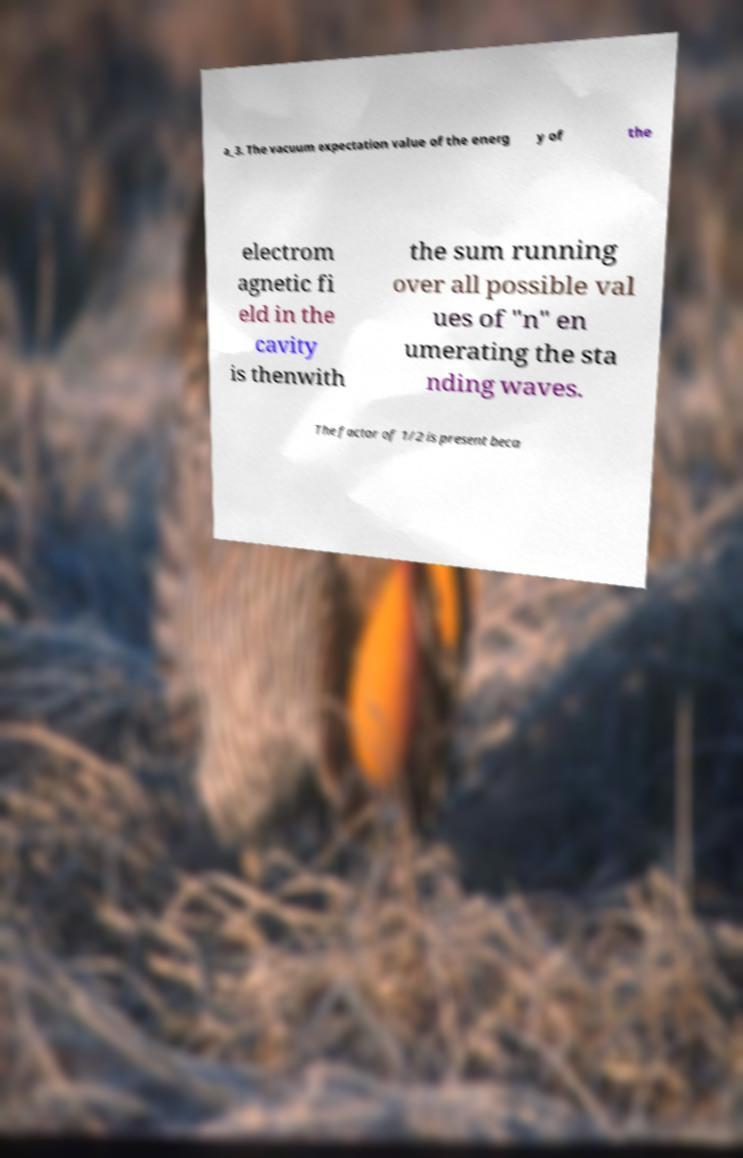Can you read and provide the text displayed in the image?This photo seems to have some interesting text. Can you extract and type it out for me? a_3. The vacuum expectation value of the energ y of the electrom agnetic fi eld in the cavity is thenwith the sum running over all possible val ues of "n" en umerating the sta nding waves. The factor of 1/2 is present beca 